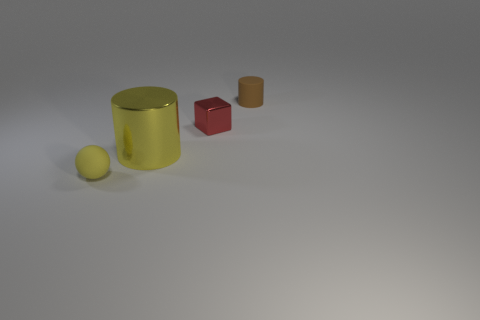Add 1 brown matte cylinders. How many objects exist? 5 Subtract all balls. How many objects are left? 3 Subtract all yellow cylinders. Subtract all tiny red blocks. How many objects are left? 2 Add 3 brown things. How many brown things are left? 4 Add 4 tiny red metallic blocks. How many tiny red metallic blocks exist? 5 Subtract 0 blue cubes. How many objects are left? 4 